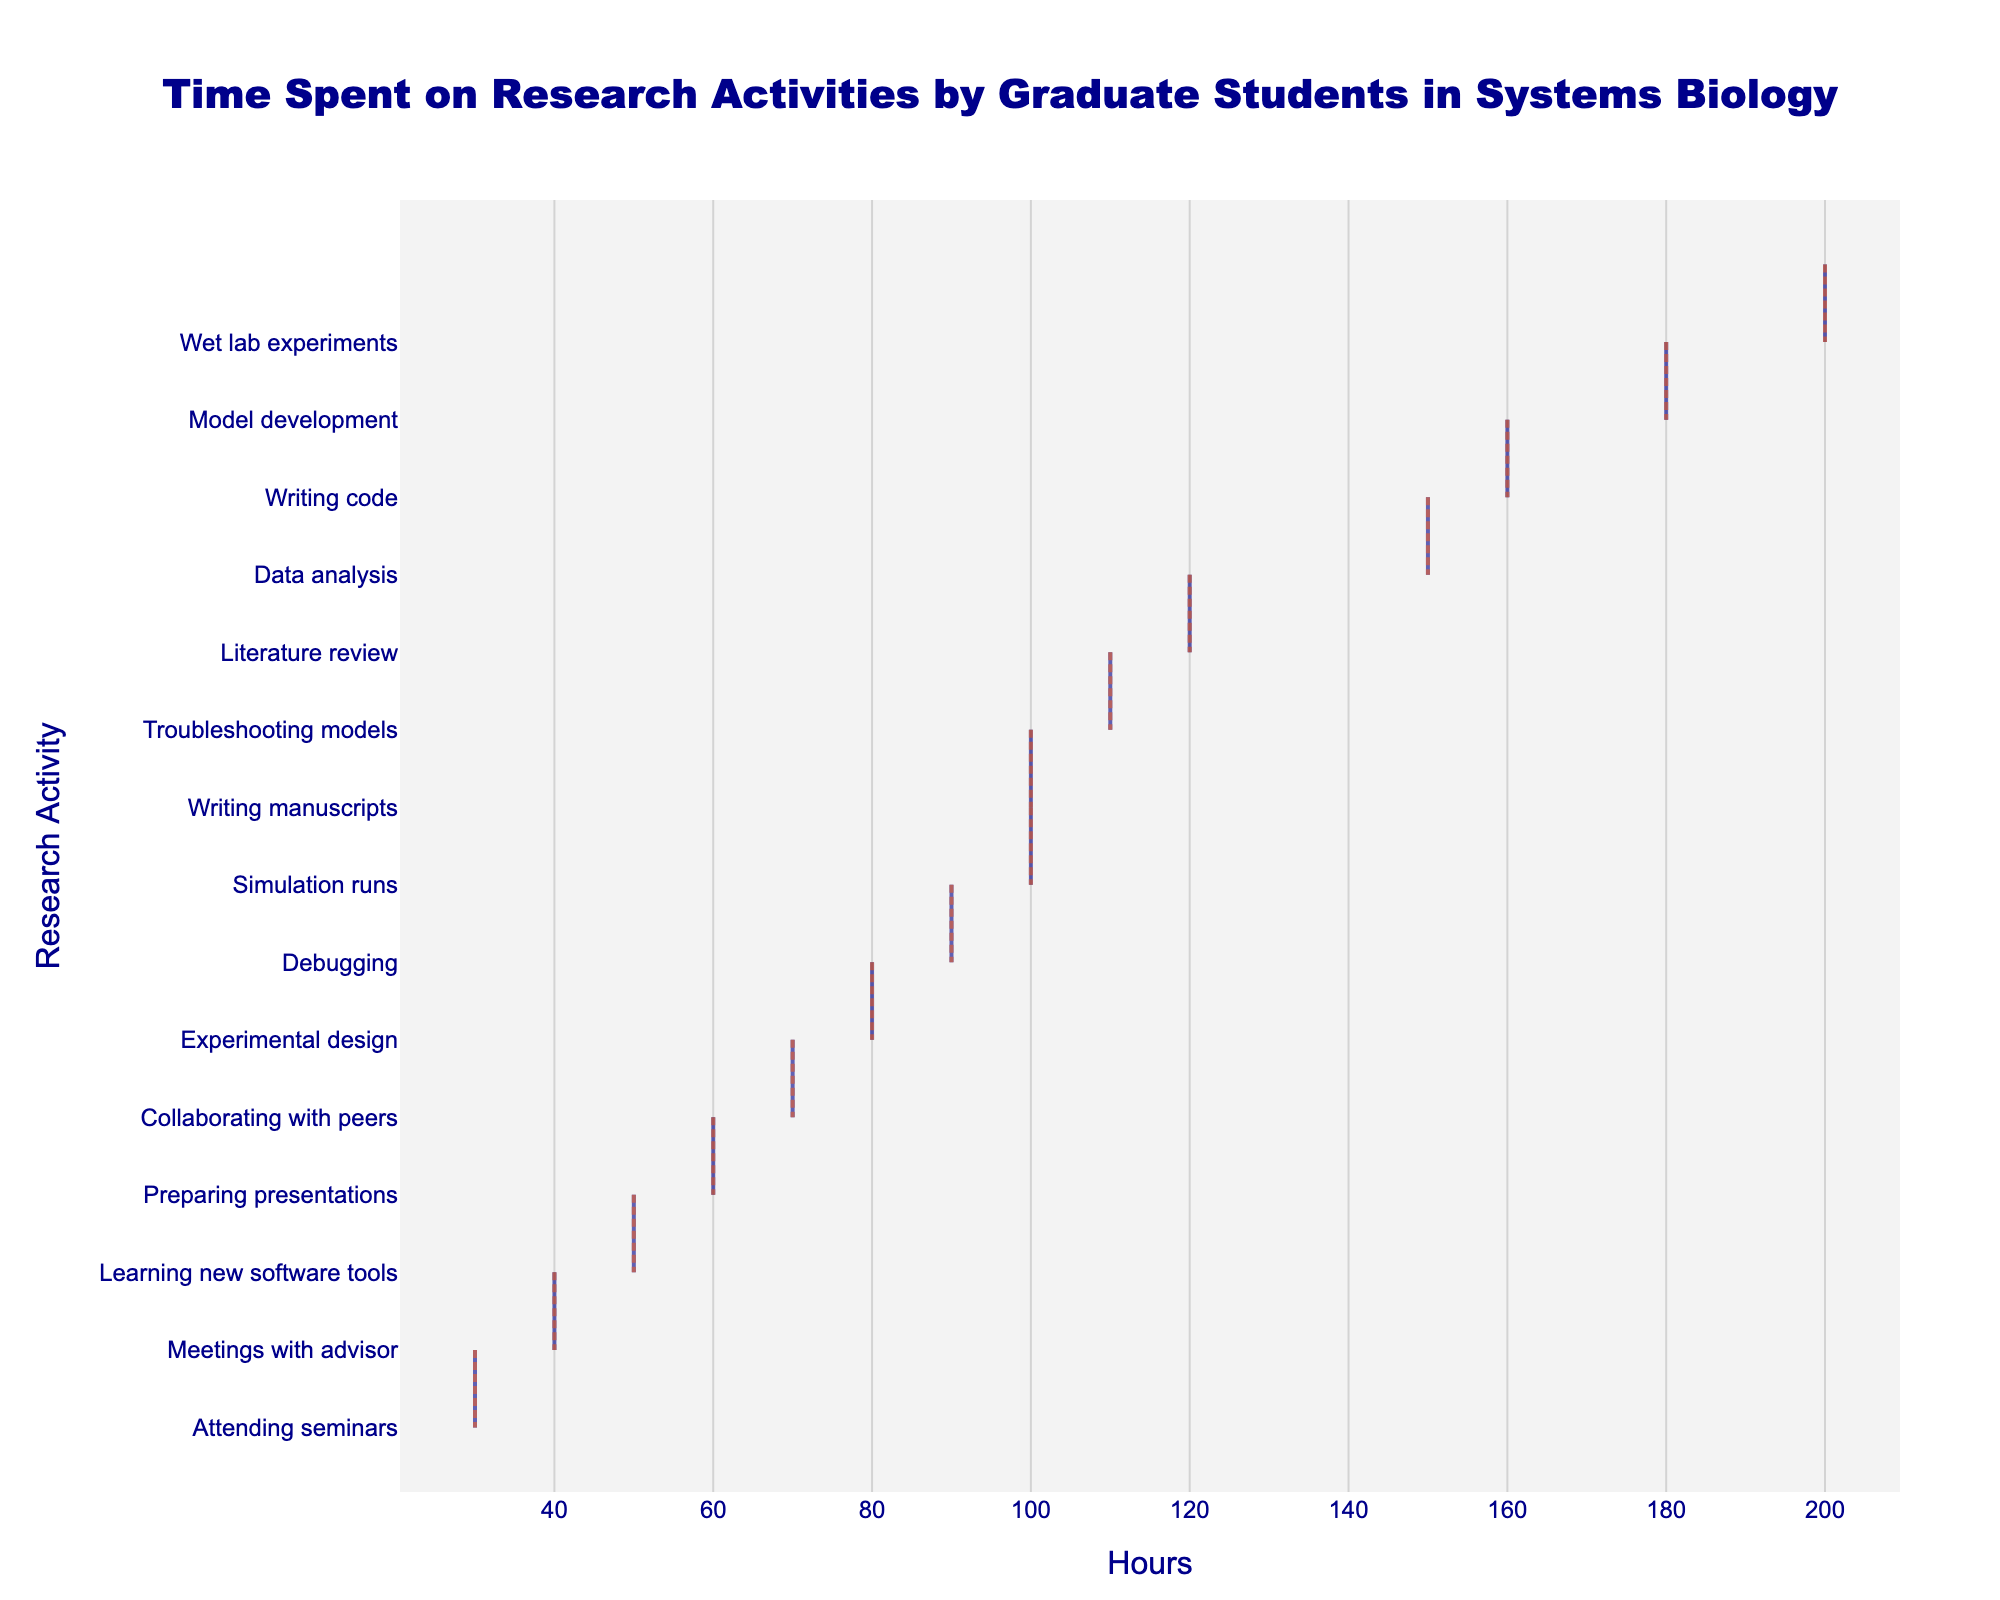What's the title of the plot? The title is displayed at the top center of the plot. It reads "Time Spent on Research Activities by Graduate Students in Systems Biology."
Answer: Time Spent on Research Activities by Graduate Students in Systems Biology What are the axis labels in the plot? The x-axis label is "Hours," and the y-axis label is "Research Activity." These labels describe the data presented on each axis of the plot.
Answer: Hours, Research Activity Which research activity has the highest number of hours? By looking at the horizontal density plot, the activity with the highest value on the x-axis is "Wet lab experiments" with 200 hours.
Answer: Wet lab experiments Which research activities have a mean line visible? The plot shows a visible mean line for each research activity indicated by a colored line across the violin.
Answer: All activities What is the total time spent on "Writing code" and "Troubleshooting models"? Sum the hours for "Writing code" (160) and "Troubleshooting models" (110). 160 + 110 = 270 hours.
Answer: 270 hours Which research activity has the lowest number of hours? By examining the leftmost point on the plot, the activity with the fewest hours is "Attending seminars" with 30 hours.
Answer: Attending seminars What is the difference in hours between "Model development" and "Writing manuscripts"? Subtract the hours for "Writing manuscripts" (100) from "Model development" (180). 180 - 100 = 80 hours.
Answer: 80 hours Are there any research activities that have the same number of hours? By examining the individual densities, it is evident that no two activities share the same horizontal extent, indicating unique hour values for each activity.
Answer: No Which research activity falls in the middle in terms of hours spent? Rank the activities by hours and identify the middle value. With 15 activities, the 8th entry after sorting is "Writing manuscripts" with 100 hours.
Answer: Writing manuscripts What is the combined time spent on "Meetings with advisor," "Preparing presentations," and "Attending seminars"? Sum the hours for the given activities: 40 (Meetings with advisor) + 60 (Preparing presentations) + 30 (Attending seminars). 40 + 60 + 30 = 130 hours.
Answer: 130 hours 